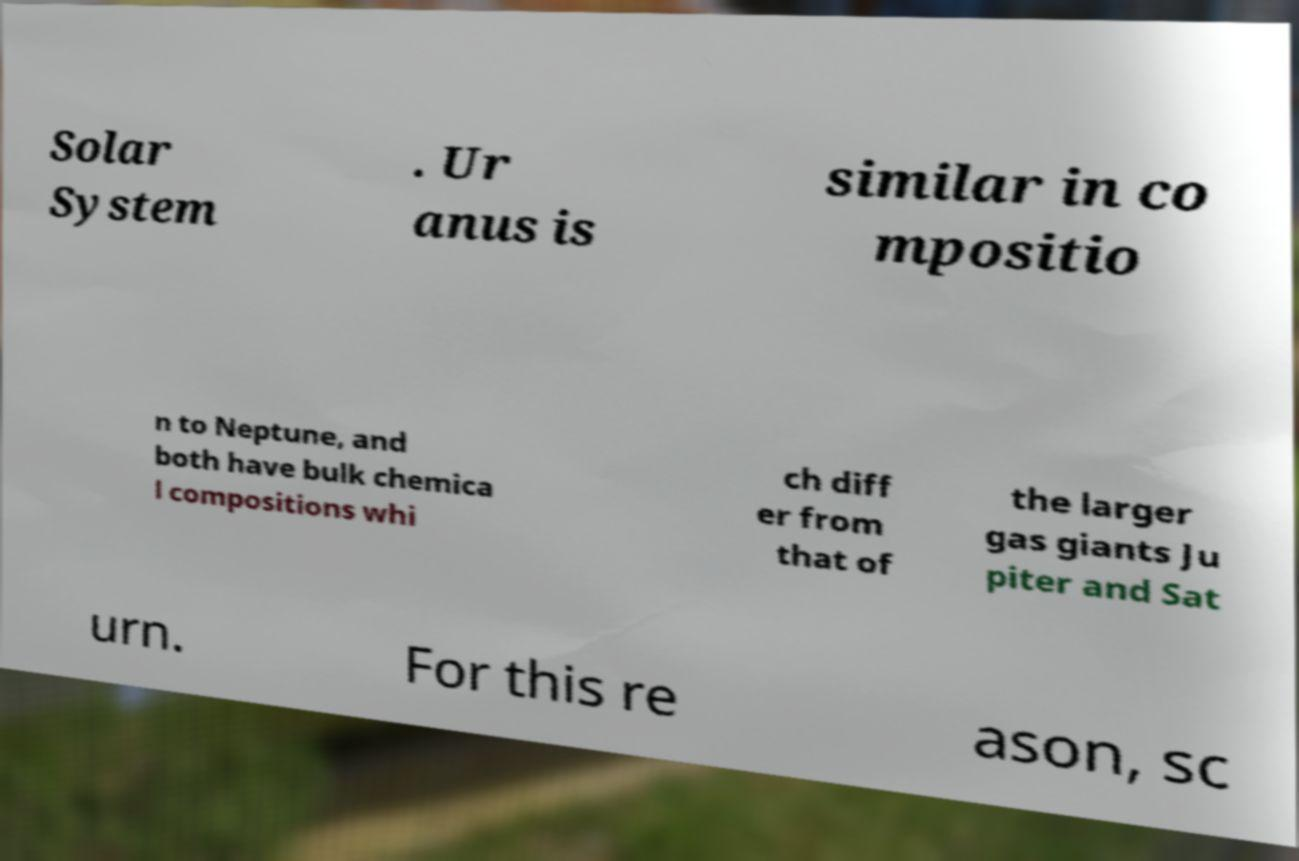Please read and relay the text visible in this image. What does it say? Solar System . Ur anus is similar in co mpositio n to Neptune, and both have bulk chemica l compositions whi ch diff er from that of the larger gas giants Ju piter and Sat urn. For this re ason, sc 